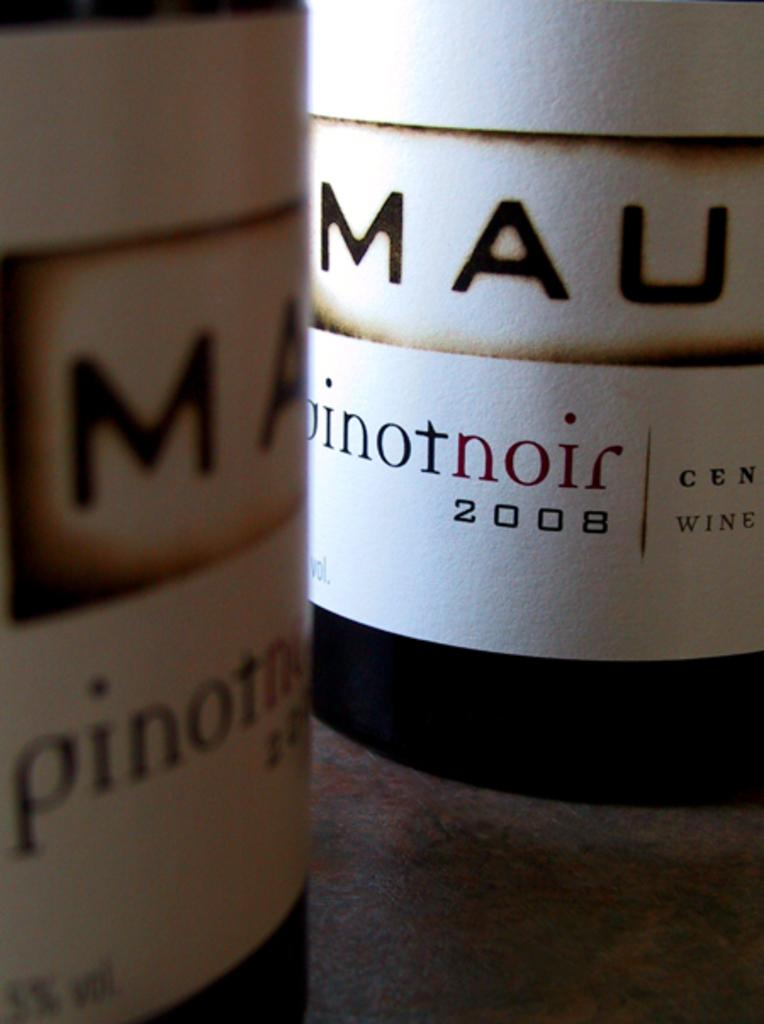<image>
Present a compact description of the photo's key features. the letters MAU are on the front of a bottle 